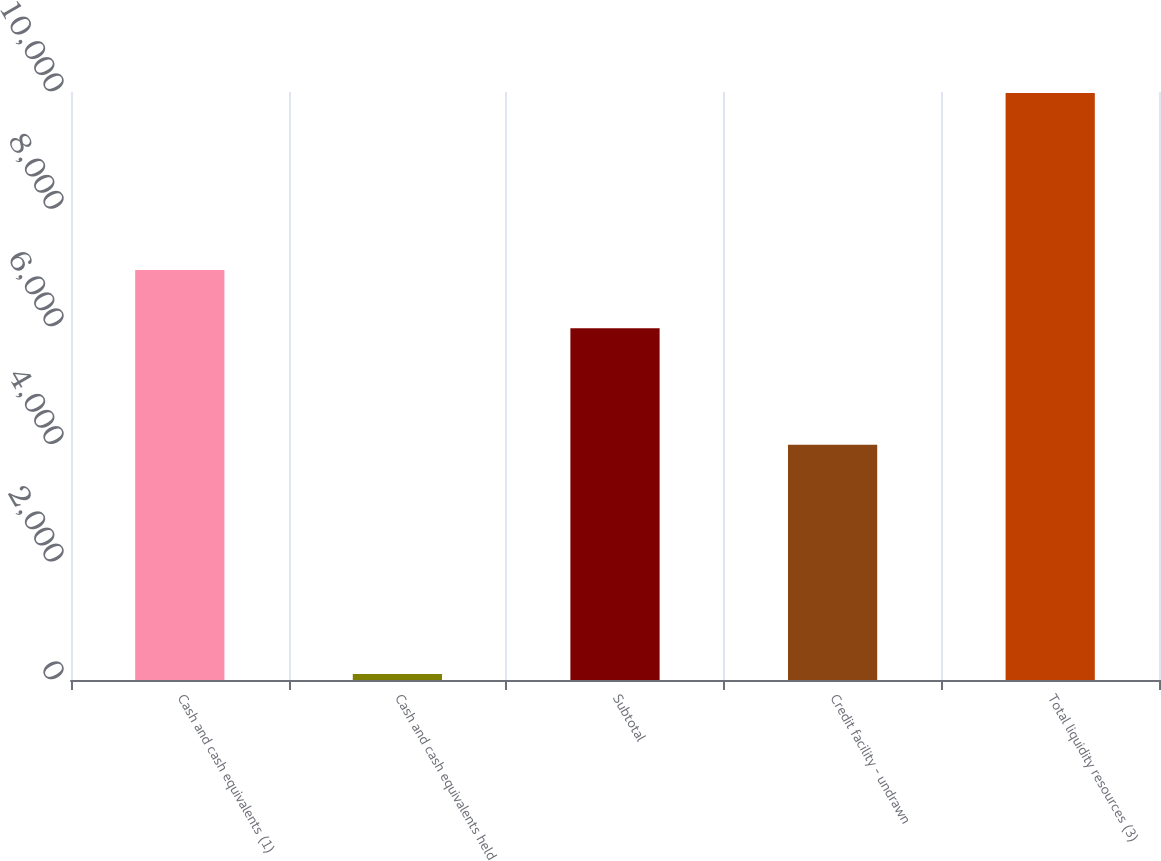Convert chart to OTSL. <chart><loc_0><loc_0><loc_500><loc_500><bar_chart><fcel>Cash and cash equivalents (1)<fcel>Cash and cash equivalents held<fcel>Subtotal<fcel>Credit facility - undrawn<fcel>Total liquidity resources (3)<nl><fcel>6971.3<fcel>100<fcel>5983<fcel>4000<fcel>9983<nl></chart> 